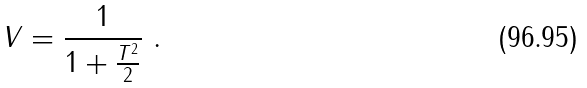<formula> <loc_0><loc_0><loc_500><loc_500>V = \frac { 1 } { 1 + \frac { T ^ { 2 } } { 2 } } \ .</formula> 